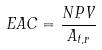<formula> <loc_0><loc_0><loc_500><loc_500>E A C = \frac { N P V } { A _ { t , r } }</formula> 